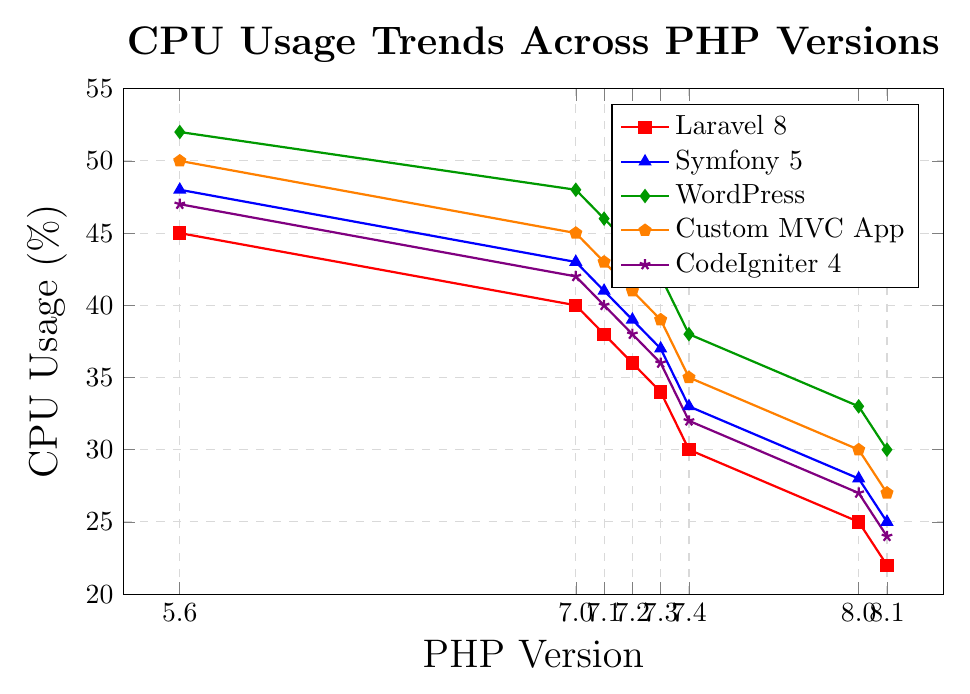What is the CPU usage percentage of Laravel 8 for PHP version 7.3? Locate the Laravel 8 series (red with square markers), then find the point corresponding to PHP version 7.3 on the x-axis. The y-value of that point represents the CPU usage percentage.
Answer: 34 Which PHP-based framework shows the highest CPU usage using PHP version 5.6? Compare the CPU usage values at PHP version 5.6 for all frameworks. The highest of these values is the answer.
Answer: WordPress Between PHP versions 7.0 and 8.1, which framework shows the greatest decrease in CPU usage? Subtract the CPU usage at PHP version 8.1 from the CPU usage at PHP version 7.0 for each framework. The framework with the largest difference is the answer.
Answer: Custom MVC App What is the average CPU usage of Symfony 5 for PHP versions 7.1, 7.3, and 8.0? Find the CPU usage for Symfony 5 (blue with triangle markers) at PHP versions 7.1, 7.3, and 8.0. Calculate the average of these values: (41+37+28)/3.
Answer: 35.33 How does the CPU usage trend of CodeIgniter 4 compare to Laravel 8 across PHP versions? Observe the direction of the trend line for both CodeIgniter 4 (violet with star markers) and Laravel 8 (red with square markers). Both frameworks' CPU usage trends show a decrease, but the exact pattern and rate of decline should be compared visually.
Answer: Both decrease Which PHP version sees the lowest CPU usage across all frameworks? Find the minimum CPU usage for each PHP version across all frameworks, then identify the PHP version associated with the overall lowest value.
Answer: PHP 8.1 By how much did the CPU usage of WordPress decrease from PHP version 7.2 to 7.4? Identify the CPU usage of WordPress at PHP versions 7.2 and 7.4. Subtract the latter from the former: 44 - 38.
Answer: 6 What is the overall trend in CPU usage for custom MVC applications as PHP versions increase? Observe the trend line for the custom MVC application (orange with pentagon markers). The line consistently decreases from PHP version 5.6 to 8.1, indicating a reduction in CPU usage.
Answer: Decreasing Which framework has the smallest difference in CPU usage between PHP versions 8.0 and 8.1? Calculate the differences in CPU usage between PHP versions 8.0 and 8.1 for each framework, and identify the smallest difference.
Answer: Laravel 8 